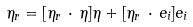Convert formula to latex. <formula><loc_0><loc_0><loc_500><loc_500>\eta _ { r } = [ \eta _ { r } \, \cdot \, \eta ] \eta + [ \eta _ { r } \, \cdot \, e _ { i } ] e _ { i }</formula> 